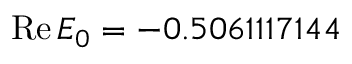Convert formula to latex. <formula><loc_0><loc_0><loc_500><loc_500>R e \, E _ { 0 } = - 0 . 5 0 6 1 1 1 7 1 4 4</formula> 